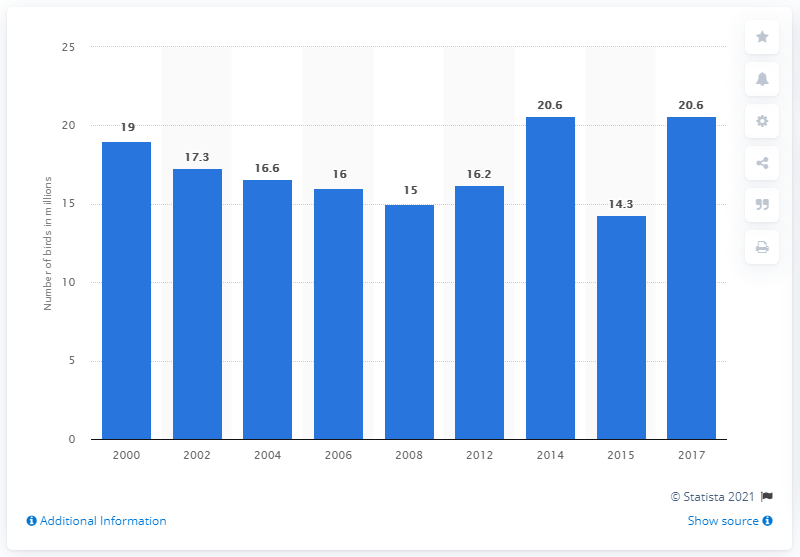Identify some key points in this picture. In 2015, the lowest number of birds owned as pets was 14.3. In 2017, it was estimated that approximately 20.6 million households in the United States owned birds as pets. 